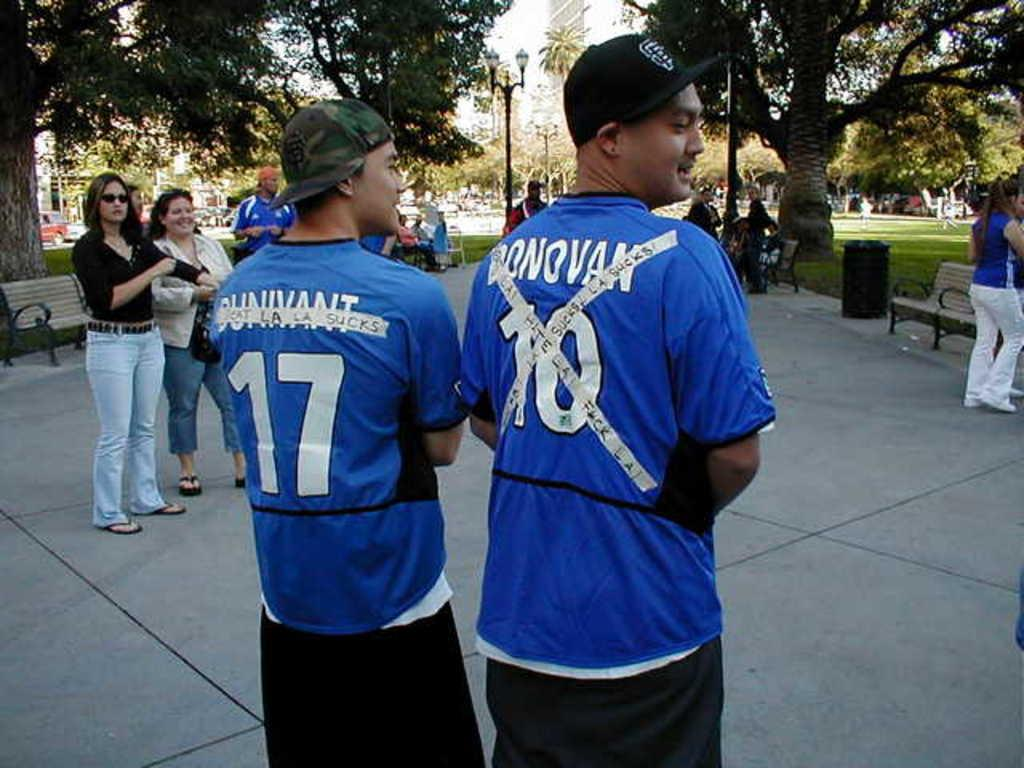<image>
Provide a brief description of the given image. a couple guys in blue shirts with one wearing the number 10 